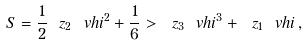<formula> <loc_0><loc_0><loc_500><loc_500>S = \frac { 1 } { 2 } \ z _ { 2 } \ v h i ^ { 2 } + \frac { 1 } { 6 } > \ z _ { 3 } \ v h i ^ { 3 } + \ z _ { 1 } \ v h i \, ,</formula> 